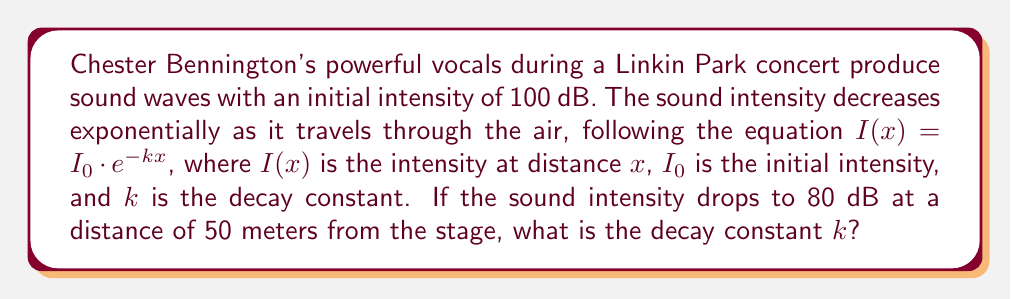Could you help me with this problem? Let's approach this step-by-step:

1) We're given the exponential decay equation:
   $I(x) = I_0 \cdot e^{-kx}$

2) We know:
   $I_0 = 100$ dB (initial intensity)
   $I(50) = 80$ dB (intensity at 50 meters)
   $x = 50$ meters

3) Substituting these values into the equation:
   $80 = 100 \cdot e^{-k(50)}$

4) Divide both sides by 100:
   $\frac{80}{100} = e^{-50k}$
   $0.8 = e^{-50k}$

5) Take the natural log of both sides:
   $\ln(0.8) = \ln(e^{-50k})$
   $\ln(0.8) = -50k$

6) Solve for $k$:
   $k = -\frac{\ln(0.8)}{50}$

7) Calculate the value:
   $k = -\frac{-0.223143551}{50} \approx 0.004463$ per meter
Answer: $k \approx 0.004463$ per meter 